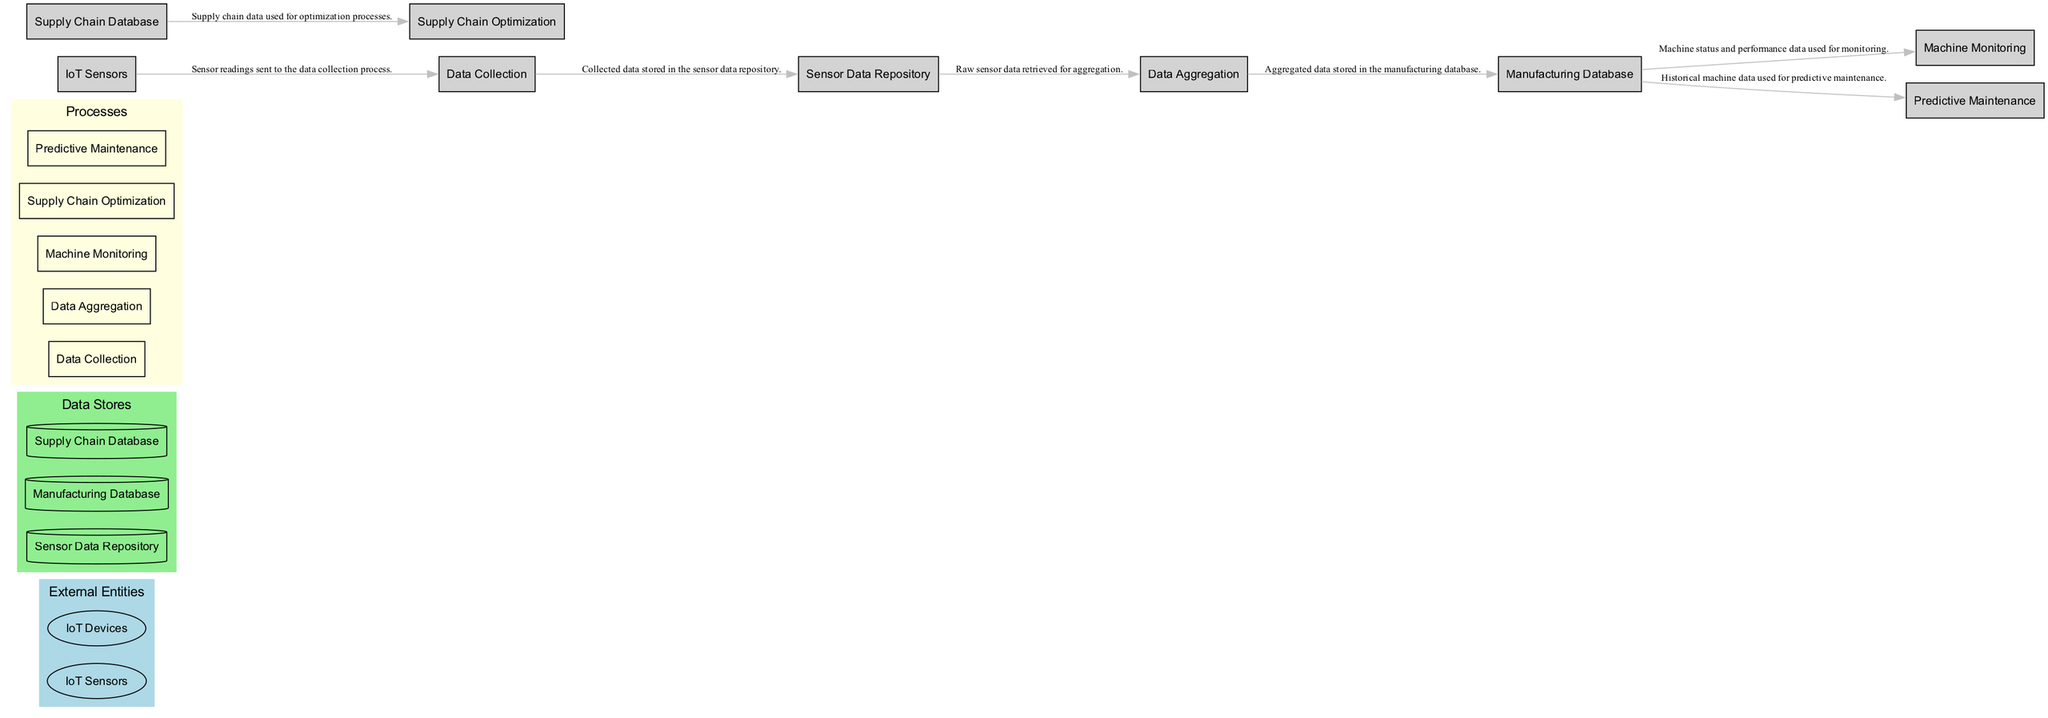What are the names of the data stores in the diagram? The data stores present in the diagram are: Sensor Data Repository, Manufacturing Database, and Supply Chain Database. They are explicitly listed in the dataStores section of the diagram.
Answer: Sensor Data Repository, Manufacturing Database, Supply Chain Database How many processes are listed in the diagram? The diagram includes a total of five processes: Data Collection, Data Aggregation, Machine Monitoring, Supply Chain Optimization, and Predictive Maintenance. This number can be counted from the processes section in the provided data.
Answer: 5 What is stored in the Sensor Data Repository? The Sensor Data Repository stores the data collected from various IoT sensors. This is specifically mentioned in the description of the Sensor Data Repository within the dataStores section.
Answer: Data collected from various IoT sensors Which process uses data from the Supply Chain Database? The process that utilizes data from the Supply Chain Database is Supply Chain Optimization, as indicated by the data flows that connect the external entity to this process in the diagram.
Answer: Supply Chain Optimization What type of data is used for Predictive Maintenance? Predictive Maintenance uses historical machine data, which is specified in the data flow connection from the Manufacturing Database to the Predictive Maintenance process.
Answer: Historical machine data How many external entities are involved in the diagram? There are two external entities present in the diagram: IoT Sensors and IoT Devices. This count can be obtained by identifying the number of entries under the externalEntities section in the data.
Answer: 2 What is the purpose of the Data Aggregation process? The Data Aggregation process's purpose is to combine data from multiple IoT sensors into a centralized repository for analysis, as described in the respective process entry.
Answer: Combine data from multiple IoT sensors What kind of insights does the Supply Chain Optimization process provide? The Supply Chain Optimization process provides IoT-driven insights to optimize inventory and logistics based on the information fed from the Supply Chain Database. This insight is derived from the description of the corresponding process.
Answer: IoT-driven insights What do IoT Devices interact with in the factory? IoT Devices interact with the factory’s systems to provide real-time data and control, as described in the external entity's section.
Answer: Factory’s systems 